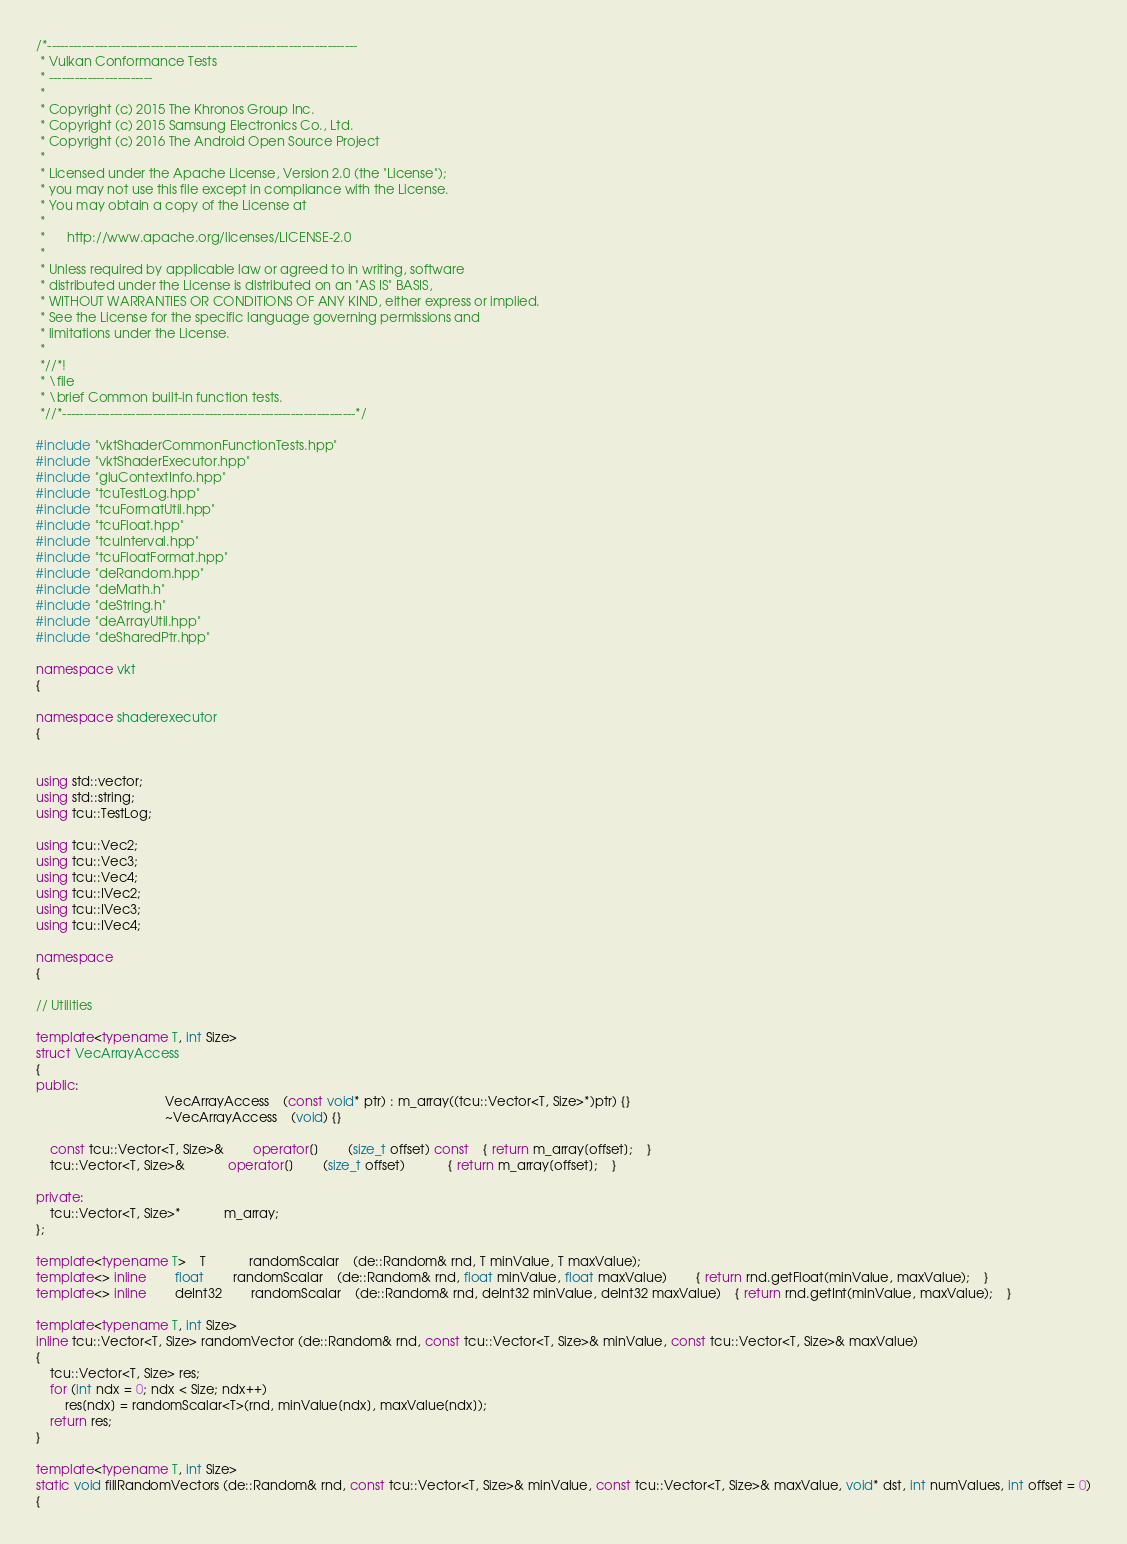Convert code to text. <code><loc_0><loc_0><loc_500><loc_500><_C++_>/*------------------------------------------------------------------------
 * Vulkan Conformance Tests
 * ------------------------
 *
 * Copyright (c) 2015 The Khronos Group Inc.
 * Copyright (c) 2015 Samsung Electronics Co., Ltd.
 * Copyright (c) 2016 The Android Open Source Project
 *
 * Licensed under the Apache License, Version 2.0 (the "License");
 * you may not use this file except in compliance with the License.
 * You may obtain a copy of the License at
 *
 *      http://www.apache.org/licenses/LICENSE-2.0
 *
 * Unless required by applicable law or agreed to in writing, software
 * distributed under the License is distributed on an "AS IS" BASIS,
 * WITHOUT WARRANTIES OR CONDITIONS OF ANY KIND, either express or implied.
 * See the License for the specific language governing permissions and
 * limitations under the License.
 *
 *//*!
 * \file
 * \brief Common built-in function tests.
 *//*--------------------------------------------------------------------*/

#include "vktShaderCommonFunctionTests.hpp"
#include "vktShaderExecutor.hpp"
#include "gluContextInfo.hpp"
#include "tcuTestLog.hpp"
#include "tcuFormatUtil.hpp"
#include "tcuFloat.hpp"
#include "tcuInterval.hpp"
#include "tcuFloatFormat.hpp"
#include "deRandom.hpp"
#include "deMath.h"
#include "deString.h"
#include "deArrayUtil.hpp"
#include "deSharedPtr.hpp"

namespace vkt
{

namespace shaderexecutor
{


using std::vector;
using std::string;
using tcu::TestLog;

using tcu::Vec2;
using tcu::Vec3;
using tcu::Vec4;
using tcu::IVec2;
using tcu::IVec3;
using tcu::IVec4;

namespace
{

// Utilities

template<typename T, int Size>
struct VecArrayAccess
{
public:
									VecArrayAccess	(const void* ptr) : m_array((tcu::Vector<T, Size>*)ptr) {}
									~VecArrayAccess	(void) {}

	const tcu::Vector<T, Size>&		operator[]		(size_t offset) const	{ return m_array[offset];	}
	tcu::Vector<T, Size>&			operator[]		(size_t offset)			{ return m_array[offset];	}

private:
	tcu::Vector<T, Size>*			m_array;
};

template<typename T>	T			randomScalar	(de::Random& rnd, T minValue, T maxValue);
template<> inline		float		randomScalar	(de::Random& rnd, float minValue, float maxValue)		{ return rnd.getFloat(minValue, maxValue);	}
template<> inline		deInt32		randomScalar	(de::Random& rnd, deInt32 minValue, deInt32 maxValue)	{ return rnd.getInt(minValue, maxValue);	}

template<typename T, int Size>
inline tcu::Vector<T, Size> randomVector (de::Random& rnd, const tcu::Vector<T, Size>& minValue, const tcu::Vector<T, Size>& maxValue)
{
	tcu::Vector<T, Size> res;
	for (int ndx = 0; ndx < Size; ndx++)
		res[ndx] = randomScalar<T>(rnd, minValue[ndx], maxValue[ndx]);
	return res;
}

template<typename T, int Size>
static void fillRandomVectors (de::Random& rnd, const tcu::Vector<T, Size>& minValue, const tcu::Vector<T, Size>& maxValue, void* dst, int numValues, int offset = 0)
{</code> 